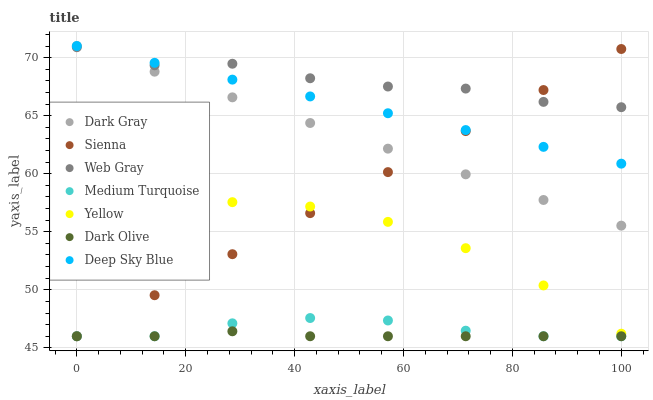Does Dark Olive have the minimum area under the curve?
Answer yes or no. Yes. Does Web Gray have the maximum area under the curve?
Answer yes or no. Yes. Does Deep Sky Blue have the minimum area under the curve?
Answer yes or no. No. Does Deep Sky Blue have the maximum area under the curve?
Answer yes or no. No. Is Sienna the smoothest?
Answer yes or no. Yes. Is Web Gray the roughest?
Answer yes or no. Yes. Is Deep Sky Blue the smoothest?
Answer yes or no. No. Is Deep Sky Blue the roughest?
Answer yes or no. No. Does Sienna have the lowest value?
Answer yes or no. Yes. Does Deep Sky Blue have the lowest value?
Answer yes or no. No. Does Dark Gray have the highest value?
Answer yes or no. Yes. Does Web Gray have the highest value?
Answer yes or no. No. Is Yellow less than Deep Sky Blue?
Answer yes or no. Yes. Is Deep Sky Blue greater than Dark Olive?
Answer yes or no. Yes. Does Medium Turquoise intersect Sienna?
Answer yes or no. Yes. Is Medium Turquoise less than Sienna?
Answer yes or no. No. Is Medium Turquoise greater than Sienna?
Answer yes or no. No. Does Yellow intersect Deep Sky Blue?
Answer yes or no. No. 